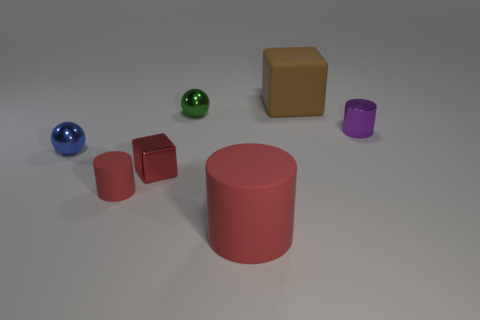Is there any pattern or symmetry in the arrangement of these objects? The arrangement of objects does not display an obvious pattern or symmetry. The objects are placed in an apparently random manner across the surface with varying distances between them, resulting in an asymmetrical composition. 